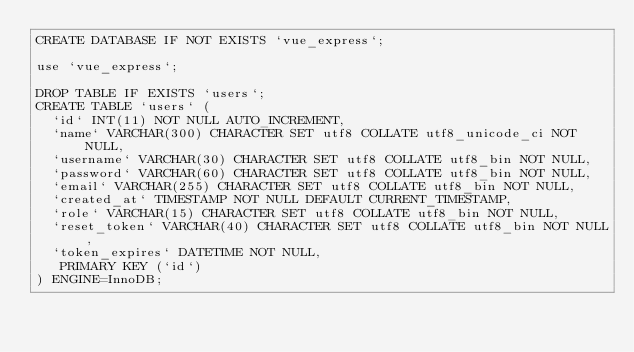<code> <loc_0><loc_0><loc_500><loc_500><_SQL_>CREATE DATABASE IF NOT EXISTS `vue_express`;

use `vue_express`;

DROP TABLE IF EXISTS `users`;
CREATE TABLE `users` (
  `id` INT(11) NOT NULL AUTO_INCREMENT,
  `name` VARCHAR(300) CHARACTER SET utf8 COLLATE utf8_unicode_ci NOT NULL,
  `username` VARCHAR(30) CHARACTER SET utf8 COLLATE utf8_bin NOT NULL,
  `password` VARCHAR(60) CHARACTER SET utf8 COLLATE utf8_bin NOT NULL,
  `email` VARCHAR(255) CHARACTER SET utf8 COLLATE utf8_bin NOT NULL,
  `created_at` TIMESTAMP NOT NULL DEFAULT CURRENT_TIMESTAMP,
  `role` VARCHAR(15) CHARACTER SET utf8 COLLATE utf8_bin NOT NULL,
  `reset_token` VARCHAR(40) CHARACTER SET utf8 COLLATE utf8_bin NOT NULL,
  `token_expires` DATETIME NOT NULL,
   PRIMARY KEY (`id`)
) ENGINE=InnoDB;
</code> 